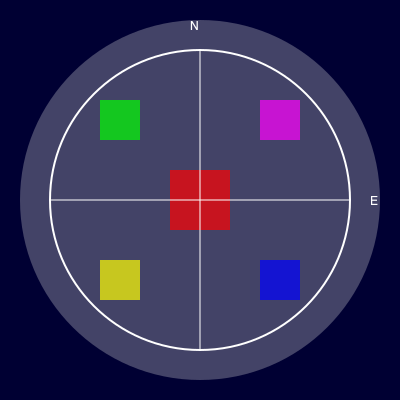In this futuristic Pluto colony layout diagram, which sector contains the largest structure, and what might its purpose be in the context of a Plutonian settlement? 1. The diagram shows a circular colony layout divided into quadrants.
2. Each quadrant contains a colored square representing a structure.
3. The largest structure is the red square in the center of the diagram.
4. Its central location suggests it's a crucial facility for the colony.
5. The size implies it houses important functions or serves as a hub.
6. In a Plutonian context, this could be:
   a) A central life support system to maintain habitable conditions
   b) An energy generation and distribution center
   c) A main transportation hub connecting different parts of the colony
   d) A communal area for gatherings and shared resources
7. Given the harsh environment of Pluto, the most critical need would be life support.
8. Therefore, the most likely purpose is a central life support system.
Answer: Central sector; likely a life support hub 